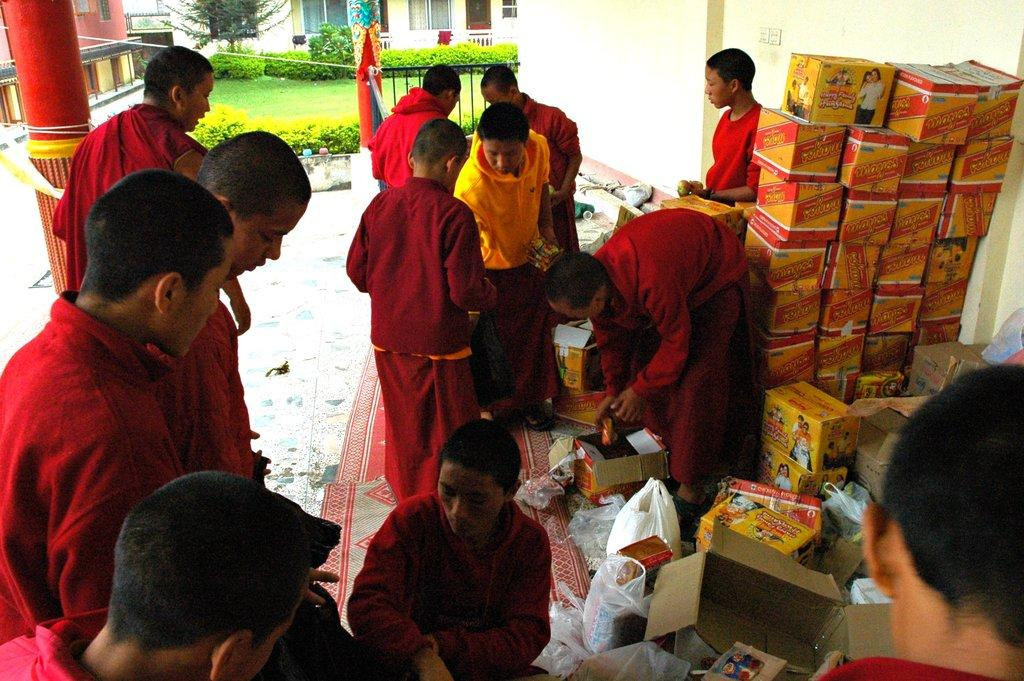How many people can be seen in the image? There are people in the image, but the exact number is not specified. What type of flooring is visible in the image? Mats are present in the image, which suggests that there is some form of flooring. What architectural feature can be seen in the image? There is a pillar in the image. What type of storage containers are present in the image? Cardboard boxes are present in the image. What type of openings are visible in the image? There are windows in the image. What type of vegetation is visible in the image? Plants and grass are visible in the image. What type of barrier is present in the image? There is a railing in the image. What type of structures are visible in the image? Buildings are visible in the image. What type of protective covering is present in the image? Plastic covers are present in the image. What type of objects can be seen in the image? There are various objects in the image. Can you tell me how many babies are crawling on the grass in the image? There is no mention of babies in the image, so we cannot determine how many might be crawling on the grass. What type of insect is visible on the pillar in the image? There is no mention of insects in the image, so we cannot determine what type might be present on the pillar. 